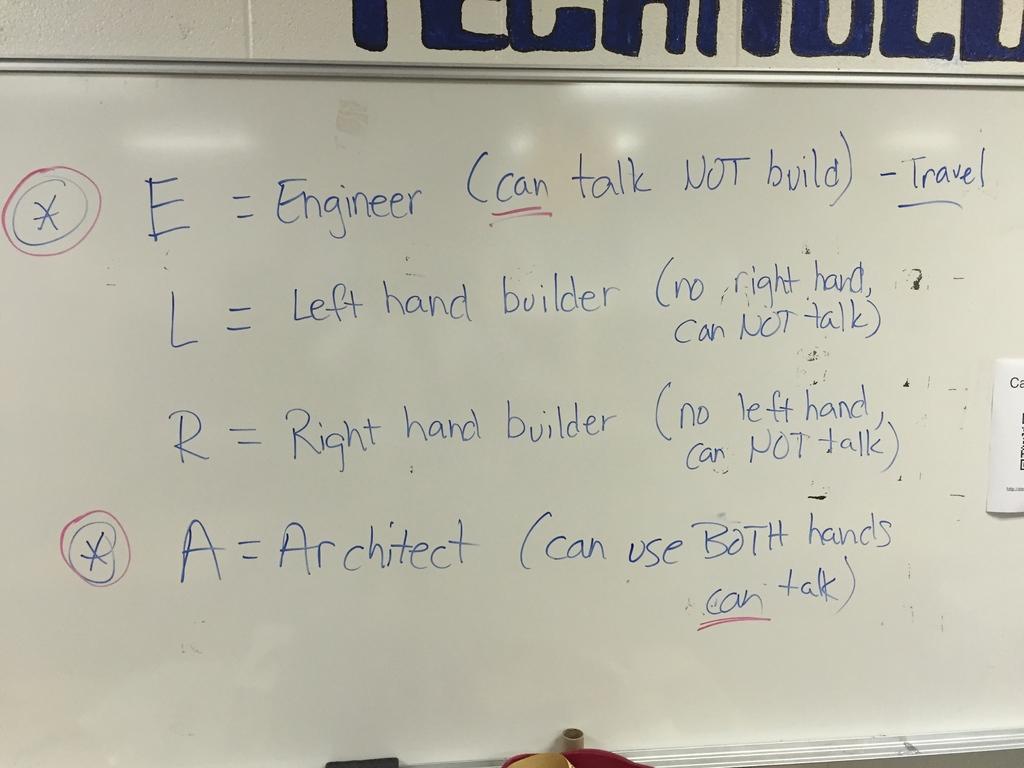What does a stand for?
Your answer should be very brief. Architect. What does e stand for?
Provide a succinct answer. Engineer. 